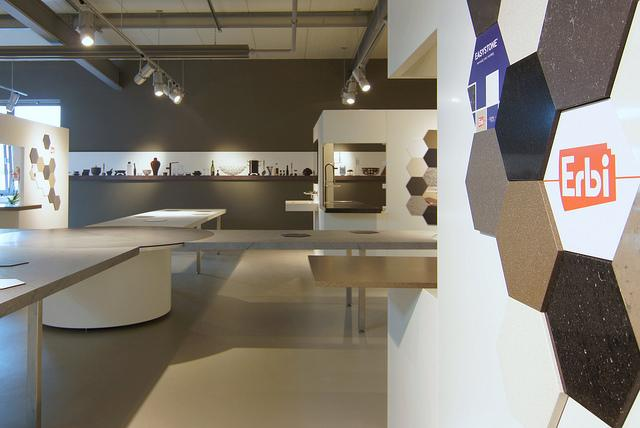This showroom specializes in which home renovation product? tables 